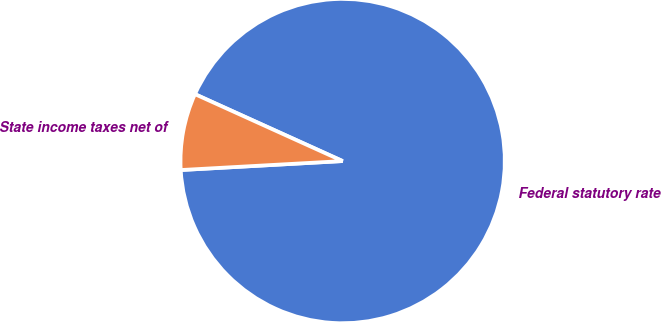Convert chart. <chart><loc_0><loc_0><loc_500><loc_500><pie_chart><fcel>Federal statutory rate<fcel>State income taxes net of<nl><fcel>92.35%<fcel>7.65%<nl></chart> 